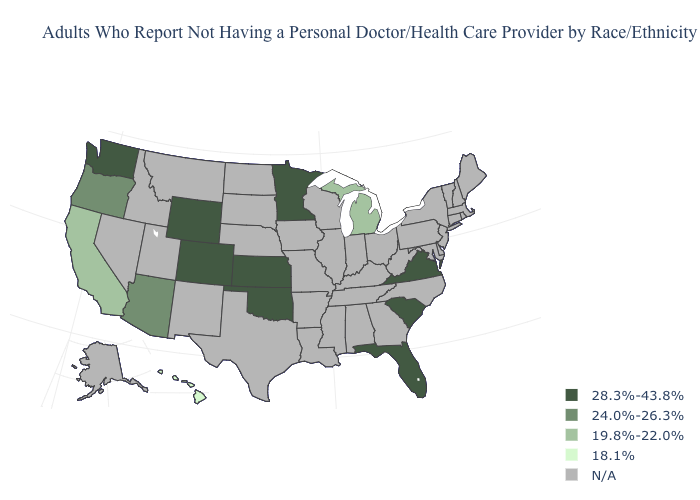What is the value of Alaska?
Concise answer only. N/A. What is the highest value in the USA?
Answer briefly. 28.3%-43.8%. Does the first symbol in the legend represent the smallest category?
Be succinct. No. Does the first symbol in the legend represent the smallest category?
Answer briefly. No. Does Hawaii have the highest value in the USA?
Concise answer only. No. What is the value of Virginia?
Short answer required. 28.3%-43.8%. What is the value of Maine?
Answer briefly. N/A. Does the map have missing data?
Give a very brief answer. Yes. Does Hawaii have the lowest value in the USA?
Quick response, please. Yes. Name the states that have a value in the range 28.3%-43.8%?
Give a very brief answer. Colorado, Florida, Kansas, Minnesota, Oklahoma, South Carolina, Virginia, Washington, Wyoming. What is the highest value in the West ?
Write a very short answer. 28.3%-43.8%. Is the legend a continuous bar?
Short answer required. No. Name the states that have a value in the range N/A?
Keep it brief. Alabama, Alaska, Arkansas, Connecticut, Delaware, Georgia, Idaho, Illinois, Indiana, Iowa, Kentucky, Louisiana, Maine, Maryland, Massachusetts, Mississippi, Missouri, Montana, Nebraska, Nevada, New Hampshire, New Jersey, New Mexico, New York, North Carolina, North Dakota, Ohio, Pennsylvania, Rhode Island, South Dakota, Tennessee, Texas, Utah, Vermont, West Virginia, Wisconsin. What is the value of West Virginia?
Be succinct. N/A. 